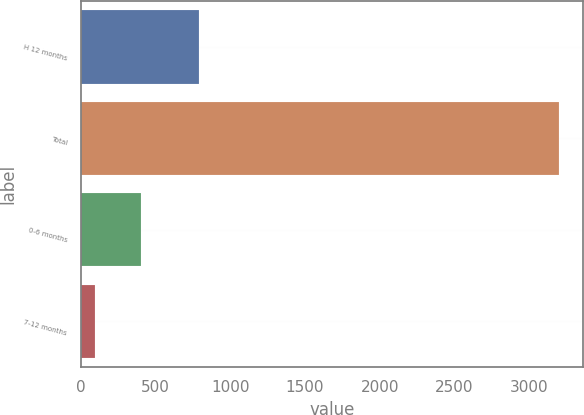<chart> <loc_0><loc_0><loc_500><loc_500><bar_chart><fcel>H 12 months<fcel>Total<fcel>0-6 months<fcel>7-12 months<nl><fcel>791<fcel>3201<fcel>403.8<fcel>93<nl></chart> 